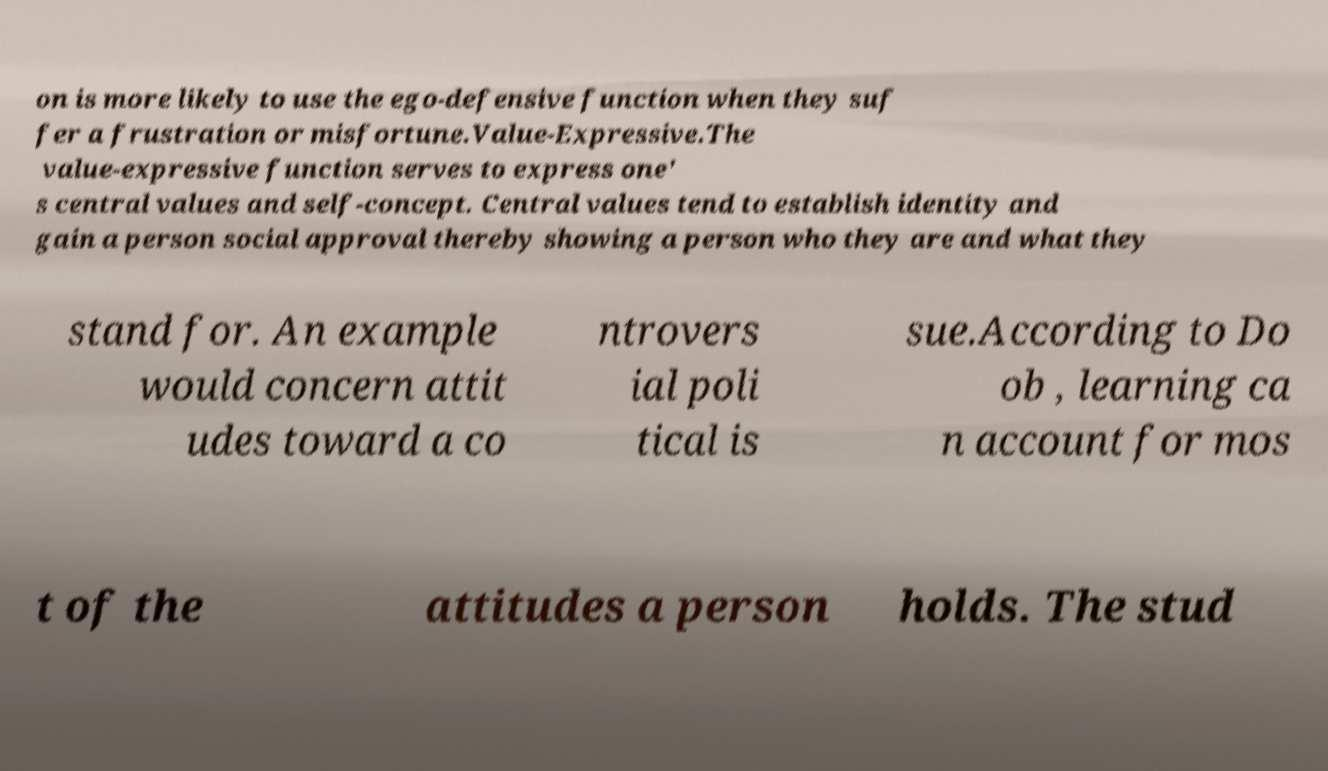I need the written content from this picture converted into text. Can you do that? on is more likely to use the ego-defensive function when they suf fer a frustration or misfortune.Value-Expressive.The value-expressive function serves to express one' s central values and self-concept. Central values tend to establish identity and gain a person social approval thereby showing a person who they are and what they stand for. An example would concern attit udes toward a co ntrovers ial poli tical is sue.According to Do ob , learning ca n account for mos t of the attitudes a person holds. The stud 